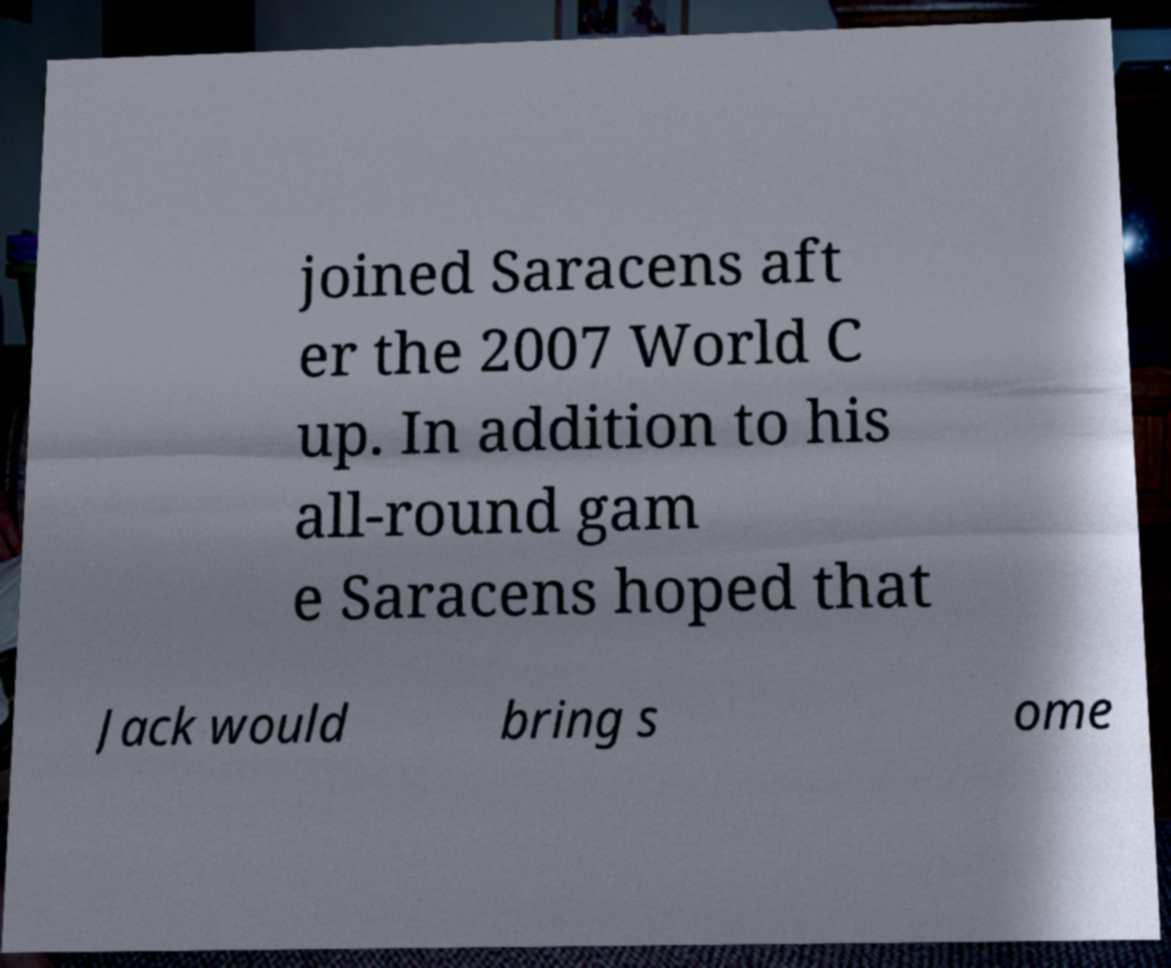For documentation purposes, I need the text within this image transcribed. Could you provide that? joined Saracens aft er the 2007 World C up. In addition to his all-round gam e Saracens hoped that Jack would bring s ome 